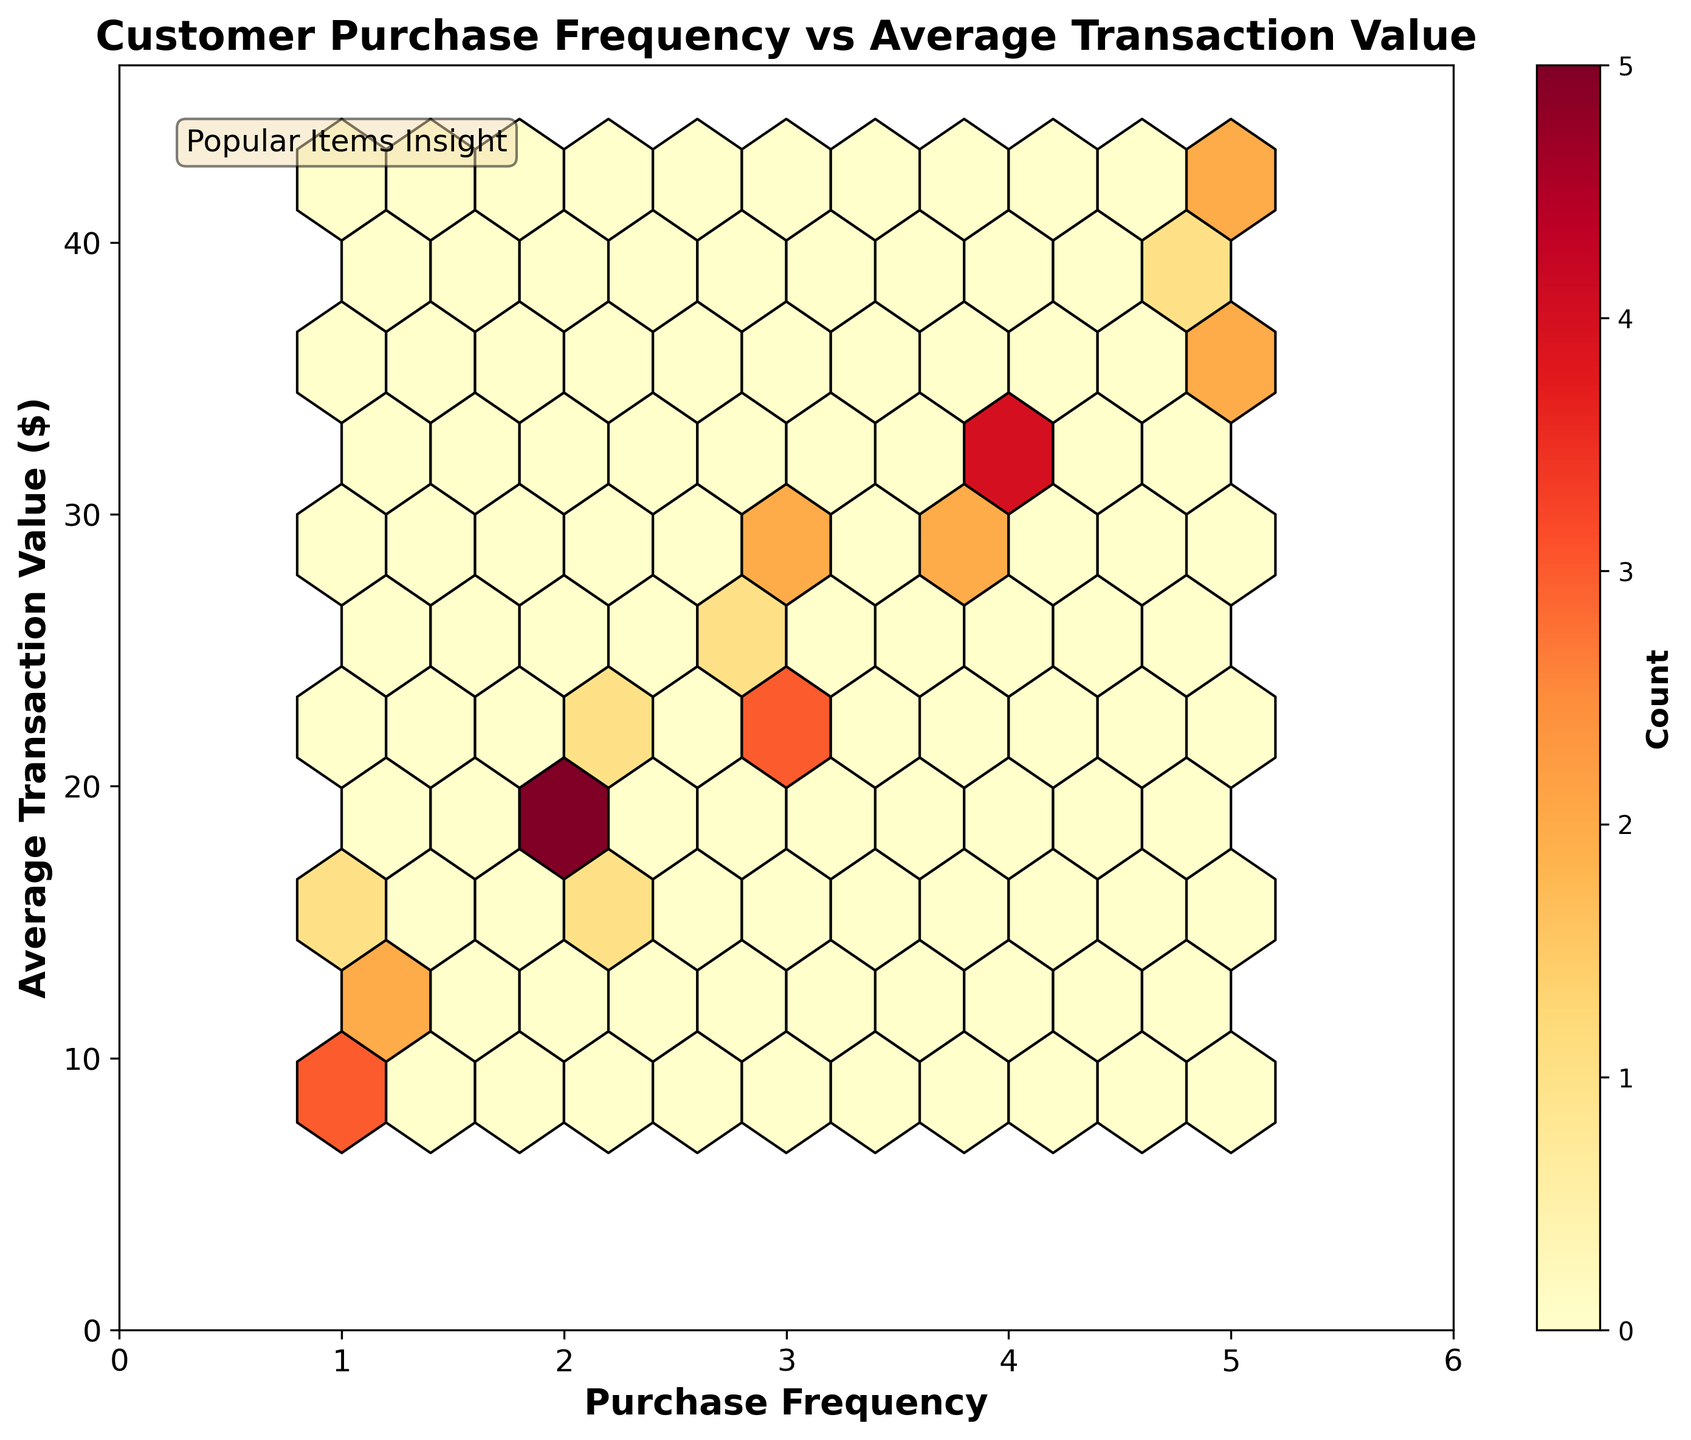what is the title of the figure? The title is typically found at the top of the figure and provides a summary of what the plot represents.
Answer: Customer Purchase Frequency vs Average Transaction Value What are the labels on the axes? The labels on the axes provide information on what each axis represents. The x-axis represents 'Purchase Frequency', and the y-axis represents 'Average Transaction Value ($)'.
Answer: Purchase Frequency and Average Transaction Value ($) What's the color scale representing? The hexbin plot uses a color scale to represent the density of data points within each hexagonal bin. Typically, lighter colors represent fewer points, while darker colors indicate more points.
Answer: Density of data points How many purchase frequencies are shown in the plot? To determine the number of different purchase frequencies, look for the distinct x-axis label values displayed in the plot. The x-axis represents the 'Purchase Frequency' ranging from 1 to 5.
Answer: 5 In which purchase frequency category is the average transaction value the highest? To identify the purchase frequency category with the highest average transaction value, observe the bin with the highest y-values and find its corresponding x-axis label. It appears that purchase frequency 5 has the highest transaction value.
Answer: 5 Where is the highest density of data points? The highest density of data points can be identified by observing the darkest hexagons on the plot. These hexagons represent areas with the highest concentration of data points. It's likely the range is around purchase frequency 3 and average transaction value 25-30.
Answer: Around Purchase Frequency 3 and Average Transaction Value 25-30 What is the range of average transaction values? By looking at the y-axis, which is labeled as 'Average Transaction Value ($)', we can see the lowest and highest values on the plot. The range is from approximately $8 to $45.
Answer: Approximately $8 to $45 How does the average transaction value vary with increasing purchase frequency? To understand this, observe the trend of the hexagons as you move from left to right on the x-axis. Generally, we notice that higher purchase frequencies tend to be associated with higher average transaction values.
Answer: Higher purchase frequencies tend to have higher average transaction values 